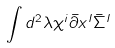Convert formula to latex. <formula><loc_0><loc_0><loc_500><loc_500>\int d ^ { 2 } \lambda \chi ^ { i } \bar { \partial } x ^ { I } \bar { \Sigma } ^ { I }</formula> 